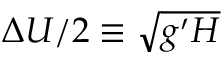<formula> <loc_0><loc_0><loc_500><loc_500>\Delta U / 2 \equiv \sqrt { g ^ { \prime } H }</formula> 